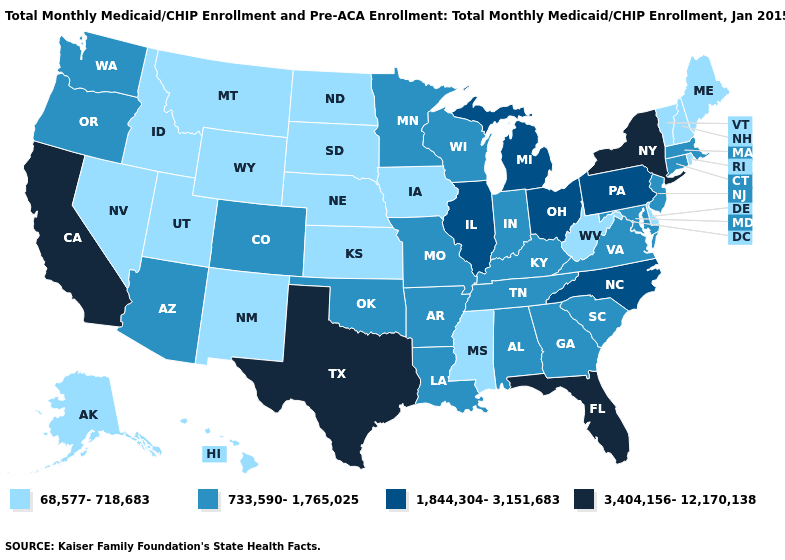Does Alaska have the lowest value in the West?
Keep it brief. Yes. What is the lowest value in the MidWest?
Answer briefly. 68,577-718,683. What is the lowest value in states that border New Jersey?
Write a very short answer. 68,577-718,683. What is the highest value in the USA?
Be succinct. 3,404,156-12,170,138. Name the states that have a value in the range 733,590-1,765,025?
Keep it brief. Alabama, Arizona, Arkansas, Colorado, Connecticut, Georgia, Indiana, Kentucky, Louisiana, Maryland, Massachusetts, Minnesota, Missouri, New Jersey, Oklahoma, Oregon, South Carolina, Tennessee, Virginia, Washington, Wisconsin. What is the value of Florida?
Quick response, please. 3,404,156-12,170,138. What is the value of Massachusetts?
Short answer required. 733,590-1,765,025. What is the value of Idaho?
Short answer required. 68,577-718,683. Among the states that border Michigan , does Ohio have the highest value?
Be succinct. Yes. Among the states that border Arkansas , which have the lowest value?
Short answer required. Mississippi. What is the lowest value in the USA?
Write a very short answer. 68,577-718,683. Does Montana have the same value as Alabama?
Answer briefly. No. Name the states that have a value in the range 1,844,304-3,151,683?
Be succinct. Illinois, Michigan, North Carolina, Ohio, Pennsylvania. Is the legend a continuous bar?
Keep it brief. No. 